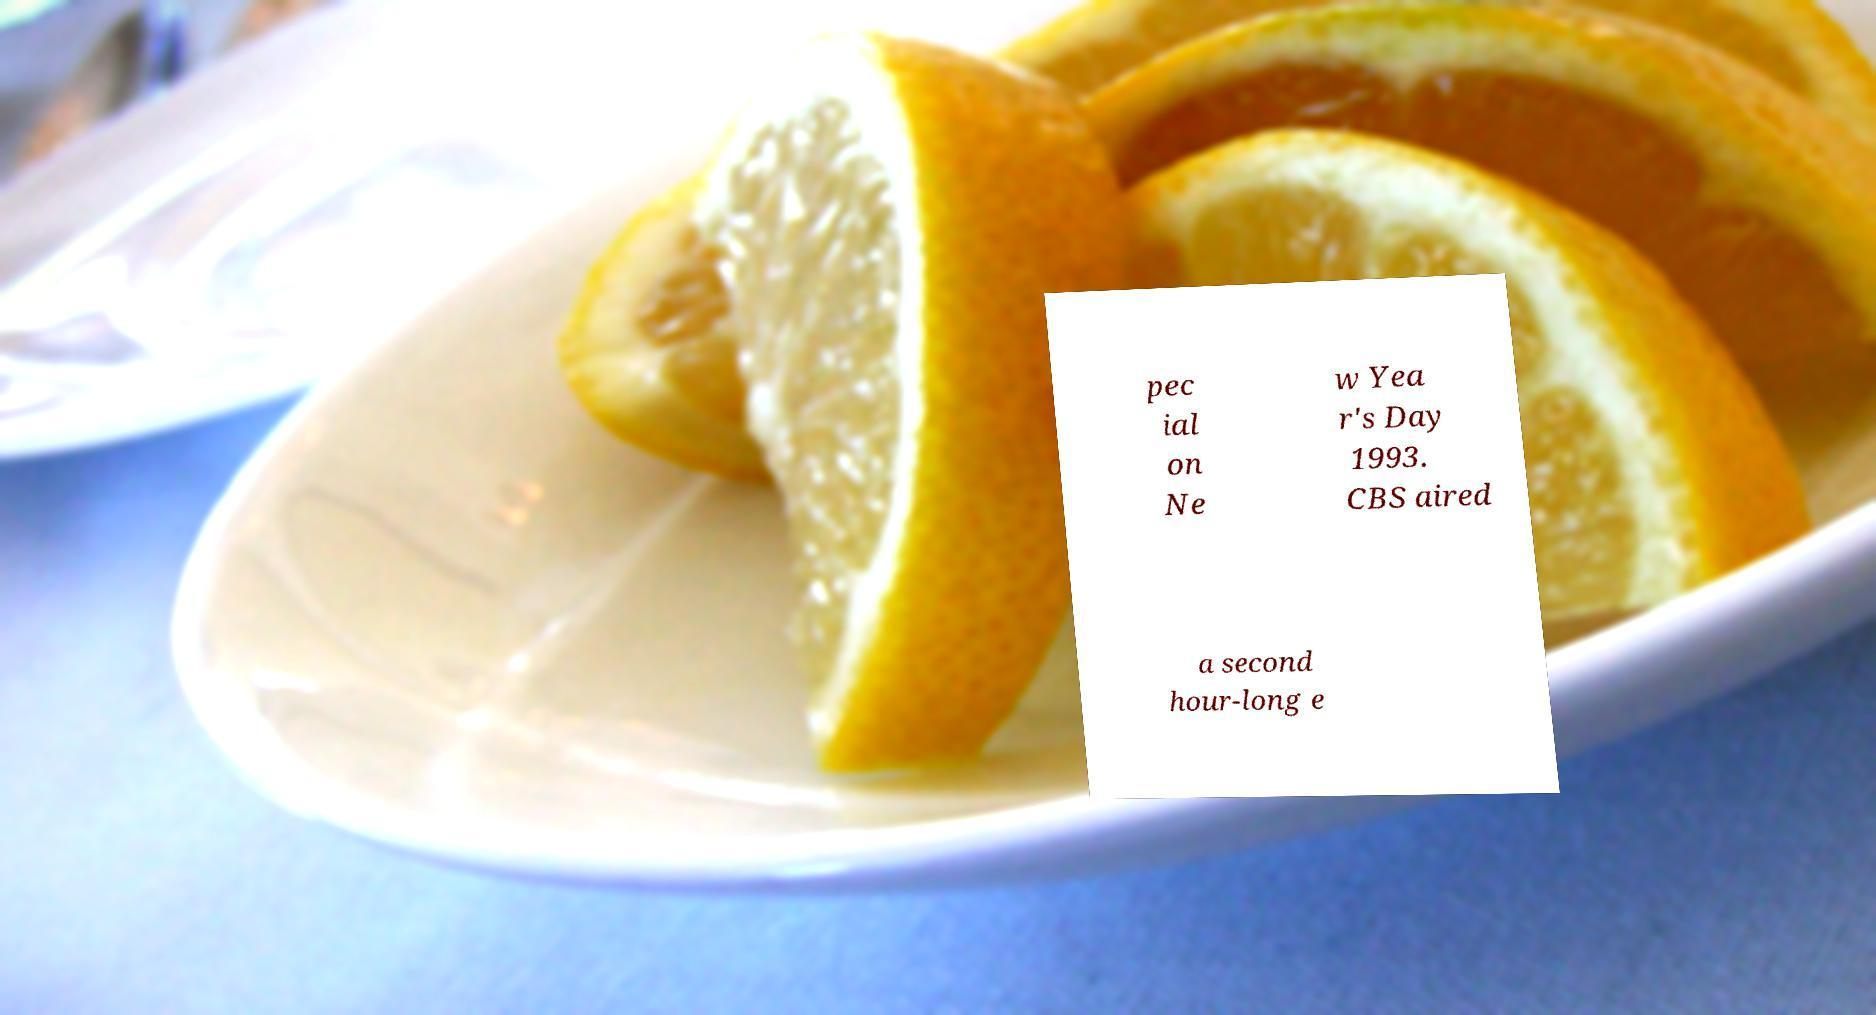Can you accurately transcribe the text from the provided image for me? pec ial on Ne w Yea r's Day 1993. CBS aired a second hour-long e 